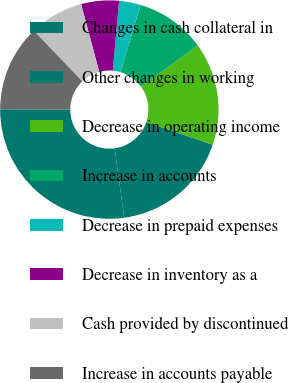<chart> <loc_0><loc_0><loc_500><loc_500><pie_chart><fcel>Changes in cash collateral in<fcel>Other changes in working<fcel>Decrease in operating income<fcel>Increase in accounts<fcel>Decrease in prepaid expenses<fcel>Decrease in inventory as a<fcel>Cash provided by discontinued<fcel>Increase in accounts payable<nl><fcel>27.22%<fcel>17.61%<fcel>15.2%<fcel>10.4%<fcel>3.19%<fcel>5.59%<fcel>7.99%<fcel>12.8%<nl></chart> 